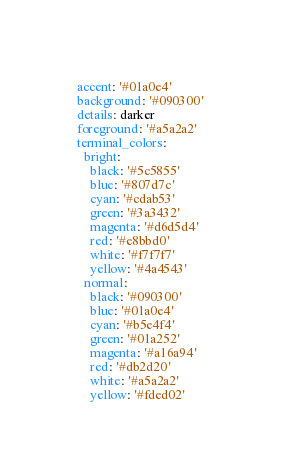<code> <loc_0><loc_0><loc_500><loc_500><_YAML_>
accent: '#01a0e4'
background: '#090300'
details: darker
foreground: '#a5a2a2'
terminal_colors: 
  bright: 
    black: '#5c5855'
    blue: '#807d7c'
    cyan: '#cdab53'
    green: '#3a3432'
    magenta: '#d6d5d4'
    red: '#e8bbd0'
    white: '#f7f7f7'
    yellow: '#4a4543'
  normal: 
    black: '#090300'
    blue: '#01a0e4'
    cyan: '#b5e4f4'
    green: '#01a252'
    magenta: '#a16a94'
    red: '#db2d20'
    white: '#a5a2a2'
    yellow: '#fded02'
</code> 